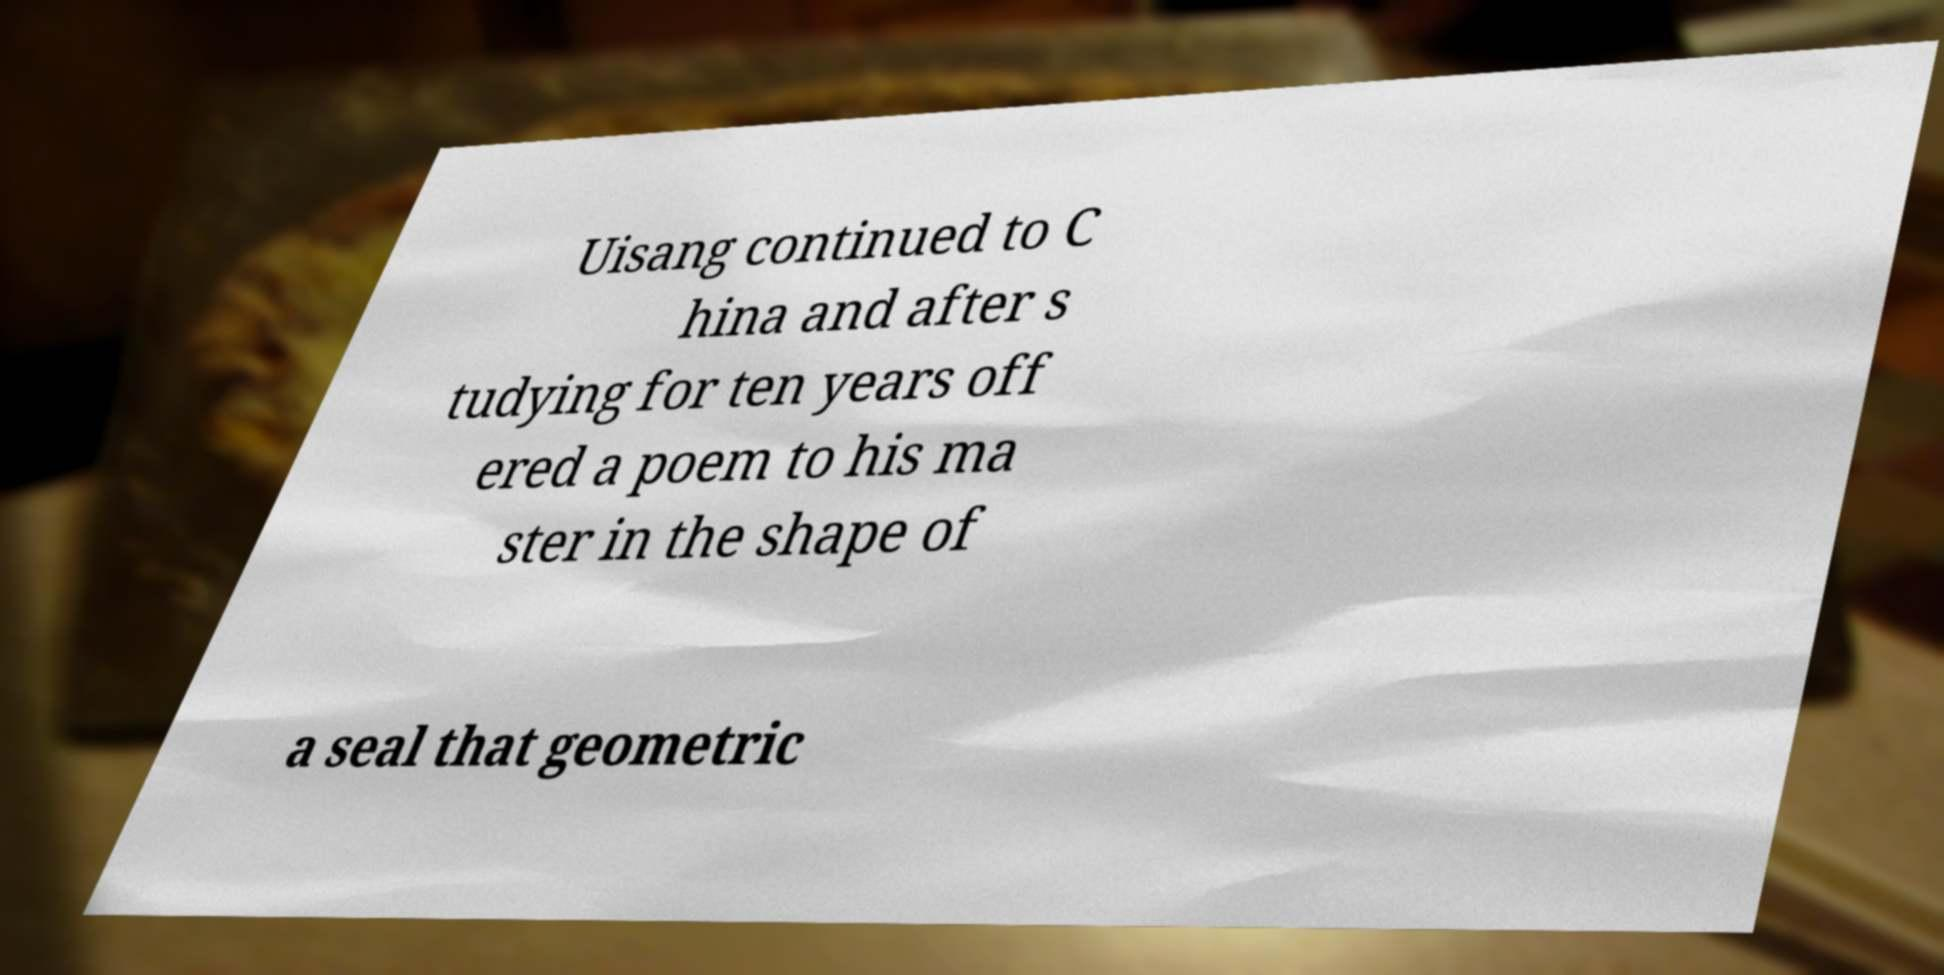For documentation purposes, I need the text within this image transcribed. Could you provide that? Uisang continued to C hina and after s tudying for ten years off ered a poem to his ma ster in the shape of a seal that geometric 